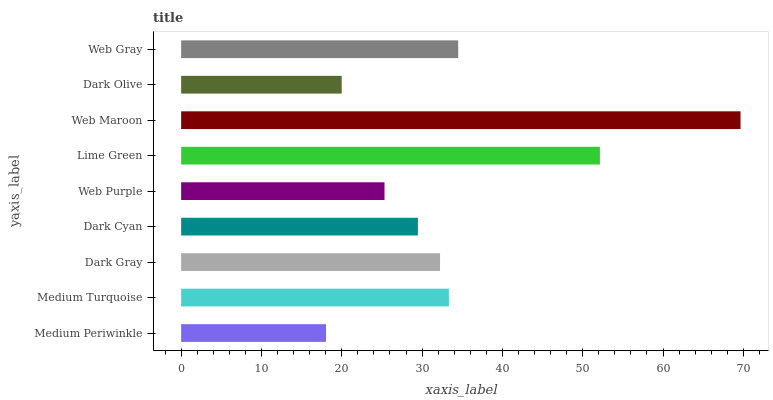Is Medium Periwinkle the minimum?
Answer yes or no. Yes. Is Web Maroon the maximum?
Answer yes or no. Yes. Is Medium Turquoise the minimum?
Answer yes or no. No. Is Medium Turquoise the maximum?
Answer yes or no. No. Is Medium Turquoise greater than Medium Periwinkle?
Answer yes or no. Yes. Is Medium Periwinkle less than Medium Turquoise?
Answer yes or no. Yes. Is Medium Periwinkle greater than Medium Turquoise?
Answer yes or no. No. Is Medium Turquoise less than Medium Periwinkle?
Answer yes or no. No. Is Dark Gray the high median?
Answer yes or no. Yes. Is Dark Gray the low median?
Answer yes or no. Yes. Is Medium Turquoise the high median?
Answer yes or no. No. Is Web Gray the low median?
Answer yes or no. No. 